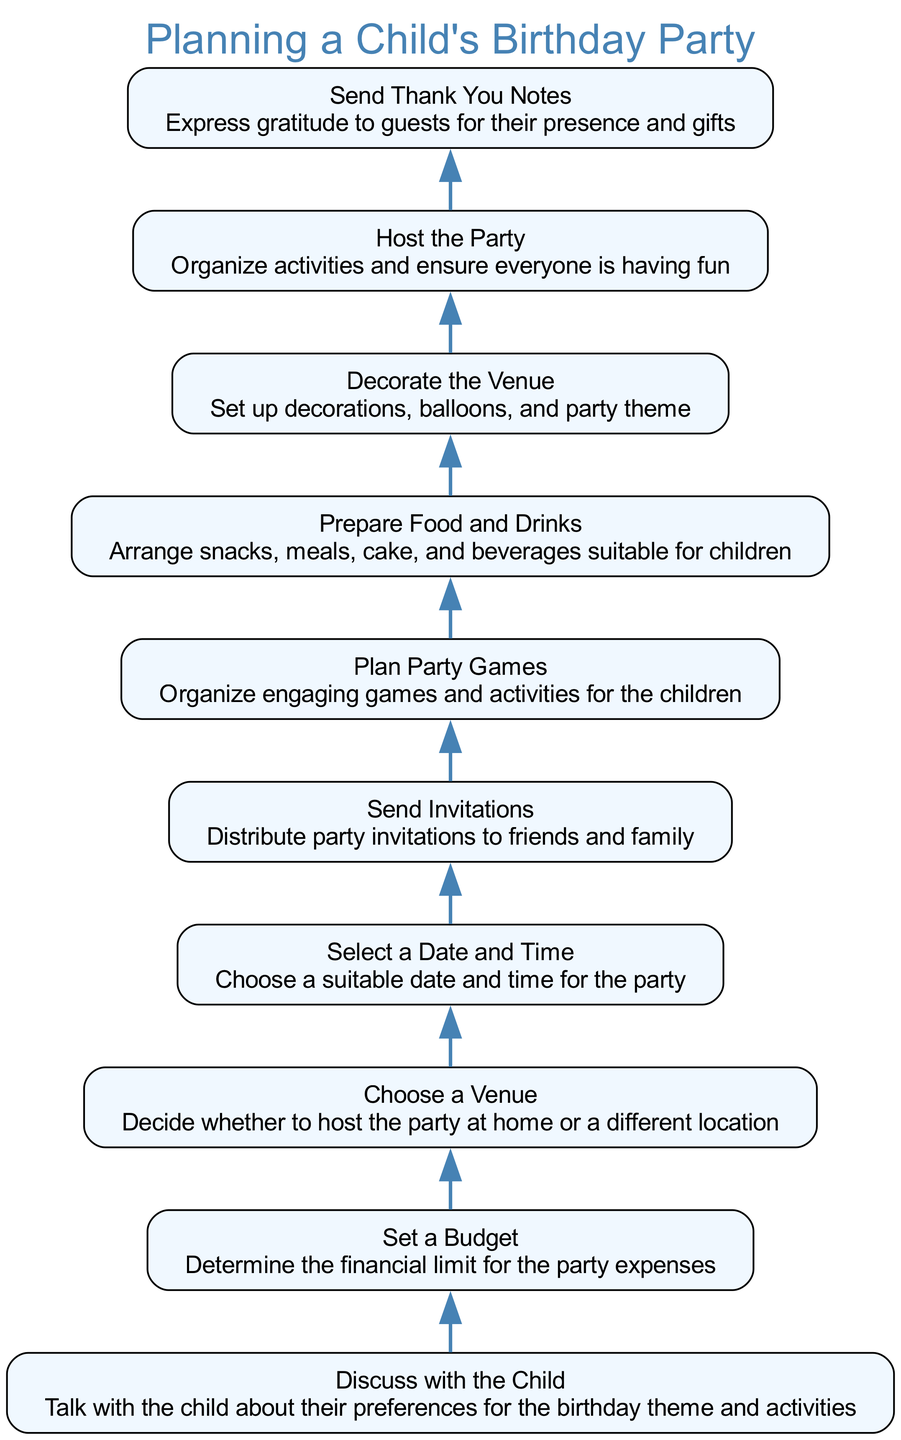What is the first step in the birthday party planning process? The last node in the flowchart represents the first step to take. Here, it shows "Discuss with the Child," which is the initial action required before moving on to setting a budget.
Answer: Discuss with the Child How many nodes are in the diagram? Counting all the nodes listed in the diagram, there are a total of 10 steps or elements shown in the flowchart.
Answer: 10 What step comes after "Prepare Food and Drinks"? According to the flow direction, the step that follows "Prepare Food and Drinks" is "Decorate the Venue." This can be seen as a direct connection in the flowchart.
Answer: Decorate the Venue Which step leads to "Host the Party"? The flowchart indicates that "Decorate the Venue" directly leads to "Host the Party." This hierarchical relationship shows the sequence of tasks involved in organizing the party.
Answer: Decorate the Venue What is the final action that needs to be taken after hosting the party? The last action indicated in the flowchart is "Send Thank You Notes," which follows after hosting the party as a way to express gratitude to the guests.
Answer: Send Thank You Notes Which step requires discussing with the child? "Discuss with the Child" is the starting point of the flowchart and it leads to "Set a Budget." Thus, it's a necessary part of the planning process before setting financial limits.
Answer: Discuss with the Child What is the relationship between "Select a Date and Time" and "Send Invitations"? The flowchart illustrates that "Select a Date and Time" leads directly to the "Send Invitations" step, making it a prerequisite for this action to take place.
Answer: Select a Date and Time Which task must be completed before choosing a venue? The task of setting a budget must be completed before choosing a venue. According to the diagram, "Set a Budget" leads to "Choose a Venue."
Answer: Set a Budget 